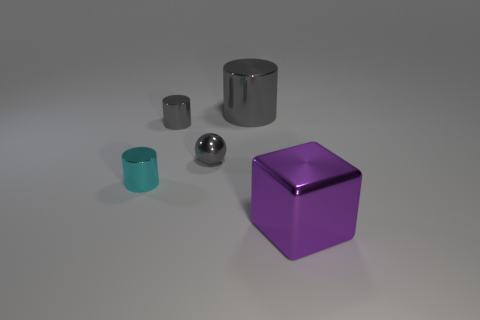Add 2 large gray objects. How many objects exist? 7 Subtract all cylinders. How many objects are left? 2 Add 2 big shiny cylinders. How many big shiny cylinders are left? 3 Add 4 red matte cubes. How many red matte cubes exist? 4 Subtract 0 red cylinders. How many objects are left? 5 Subtract all small green rubber objects. Subtract all cylinders. How many objects are left? 2 